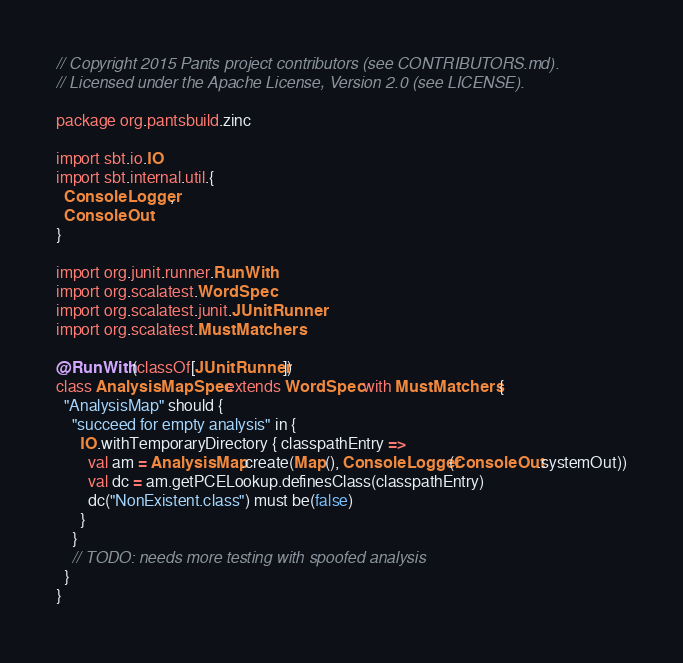<code> <loc_0><loc_0><loc_500><loc_500><_Scala_>// Copyright 2015 Pants project contributors (see CONTRIBUTORS.md).
// Licensed under the Apache License, Version 2.0 (see LICENSE).

package org.pantsbuild.zinc

import sbt.io.IO
import sbt.internal.util.{
  ConsoleLogger,
  ConsoleOut
}

import org.junit.runner.RunWith
import org.scalatest.WordSpec
import org.scalatest.junit.JUnitRunner
import org.scalatest.MustMatchers

@RunWith(classOf[JUnitRunner])
class AnalysisMapSpec extends WordSpec with MustMatchers {
  "AnalysisMap" should {
    "succeed for empty analysis" in {
      IO.withTemporaryDirectory { classpathEntry =>
        val am = AnalysisMap.create(Map(), ConsoleLogger(ConsoleOut.systemOut))
        val dc = am.getPCELookup.definesClass(classpathEntry)
        dc("NonExistent.class") must be(false)
      }
    }
    // TODO: needs more testing with spoofed analysis
  }
}
</code> 